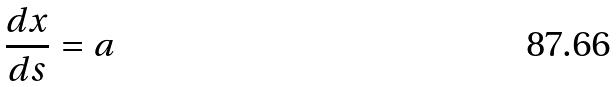<formula> <loc_0><loc_0><loc_500><loc_500>\frac { d x } { d s } = a</formula> 